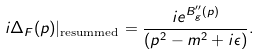Convert formula to latex. <formula><loc_0><loc_0><loc_500><loc_500>i \Delta _ { F } ( p ) | _ { \text {resummed} } = \frac { i e ^ { B ^ { \prime \prime } _ { g } ( p ) } } { ( p ^ { 2 } - m ^ { 2 } + i \epsilon ) } .</formula> 